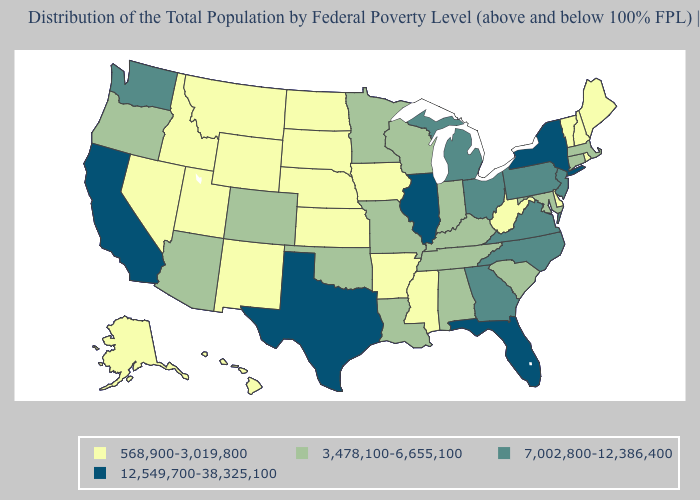What is the value of Kansas?
Keep it brief. 568,900-3,019,800. Does Hawaii have the lowest value in the USA?
Keep it brief. Yes. Which states hav the highest value in the West?
Give a very brief answer. California. Among the states that border Idaho , does Oregon have the lowest value?
Quick response, please. No. Name the states that have a value in the range 7,002,800-12,386,400?
Answer briefly. Georgia, Michigan, New Jersey, North Carolina, Ohio, Pennsylvania, Virginia, Washington. Is the legend a continuous bar?
Short answer required. No. Name the states that have a value in the range 3,478,100-6,655,100?
Short answer required. Alabama, Arizona, Colorado, Connecticut, Indiana, Kentucky, Louisiana, Maryland, Massachusetts, Minnesota, Missouri, Oklahoma, Oregon, South Carolina, Tennessee, Wisconsin. Does Illinois have the highest value in the USA?
Keep it brief. Yes. Among the states that border Wisconsin , which have the highest value?
Concise answer only. Illinois. Which states have the highest value in the USA?
Write a very short answer. California, Florida, Illinois, New York, Texas. What is the value of Missouri?
Answer briefly. 3,478,100-6,655,100. Among the states that border Connecticut , which have the lowest value?
Quick response, please. Rhode Island. What is the value of Rhode Island?
Keep it brief. 568,900-3,019,800. Does Arizona have the highest value in the West?
Short answer required. No. Does Maine have the lowest value in the Northeast?
Concise answer only. Yes. 